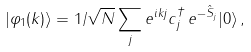<formula> <loc_0><loc_0><loc_500><loc_500>| \varphi _ { 1 } ( k ) \rangle = 1 / \sqrt { N } \sum _ { j } e ^ { i k j } c ^ { \dagger } _ { j } \, e ^ { - \hat { S } _ { j } } | 0 \rangle \, ,</formula> 